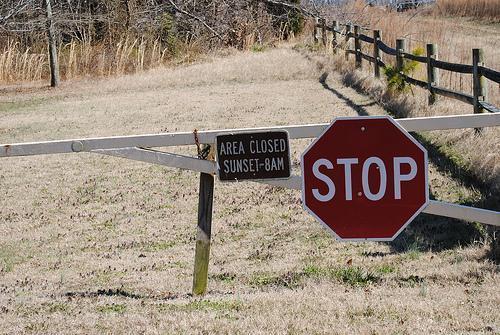How many signs are there?
Give a very brief answer. 2. 